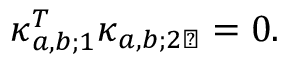<formula> <loc_0><loc_0><loc_500><loc_500>\kappa _ { a , b ; 1 } ^ { T } \kappa _ { a , b ; 2 \perp } = 0 .</formula> 